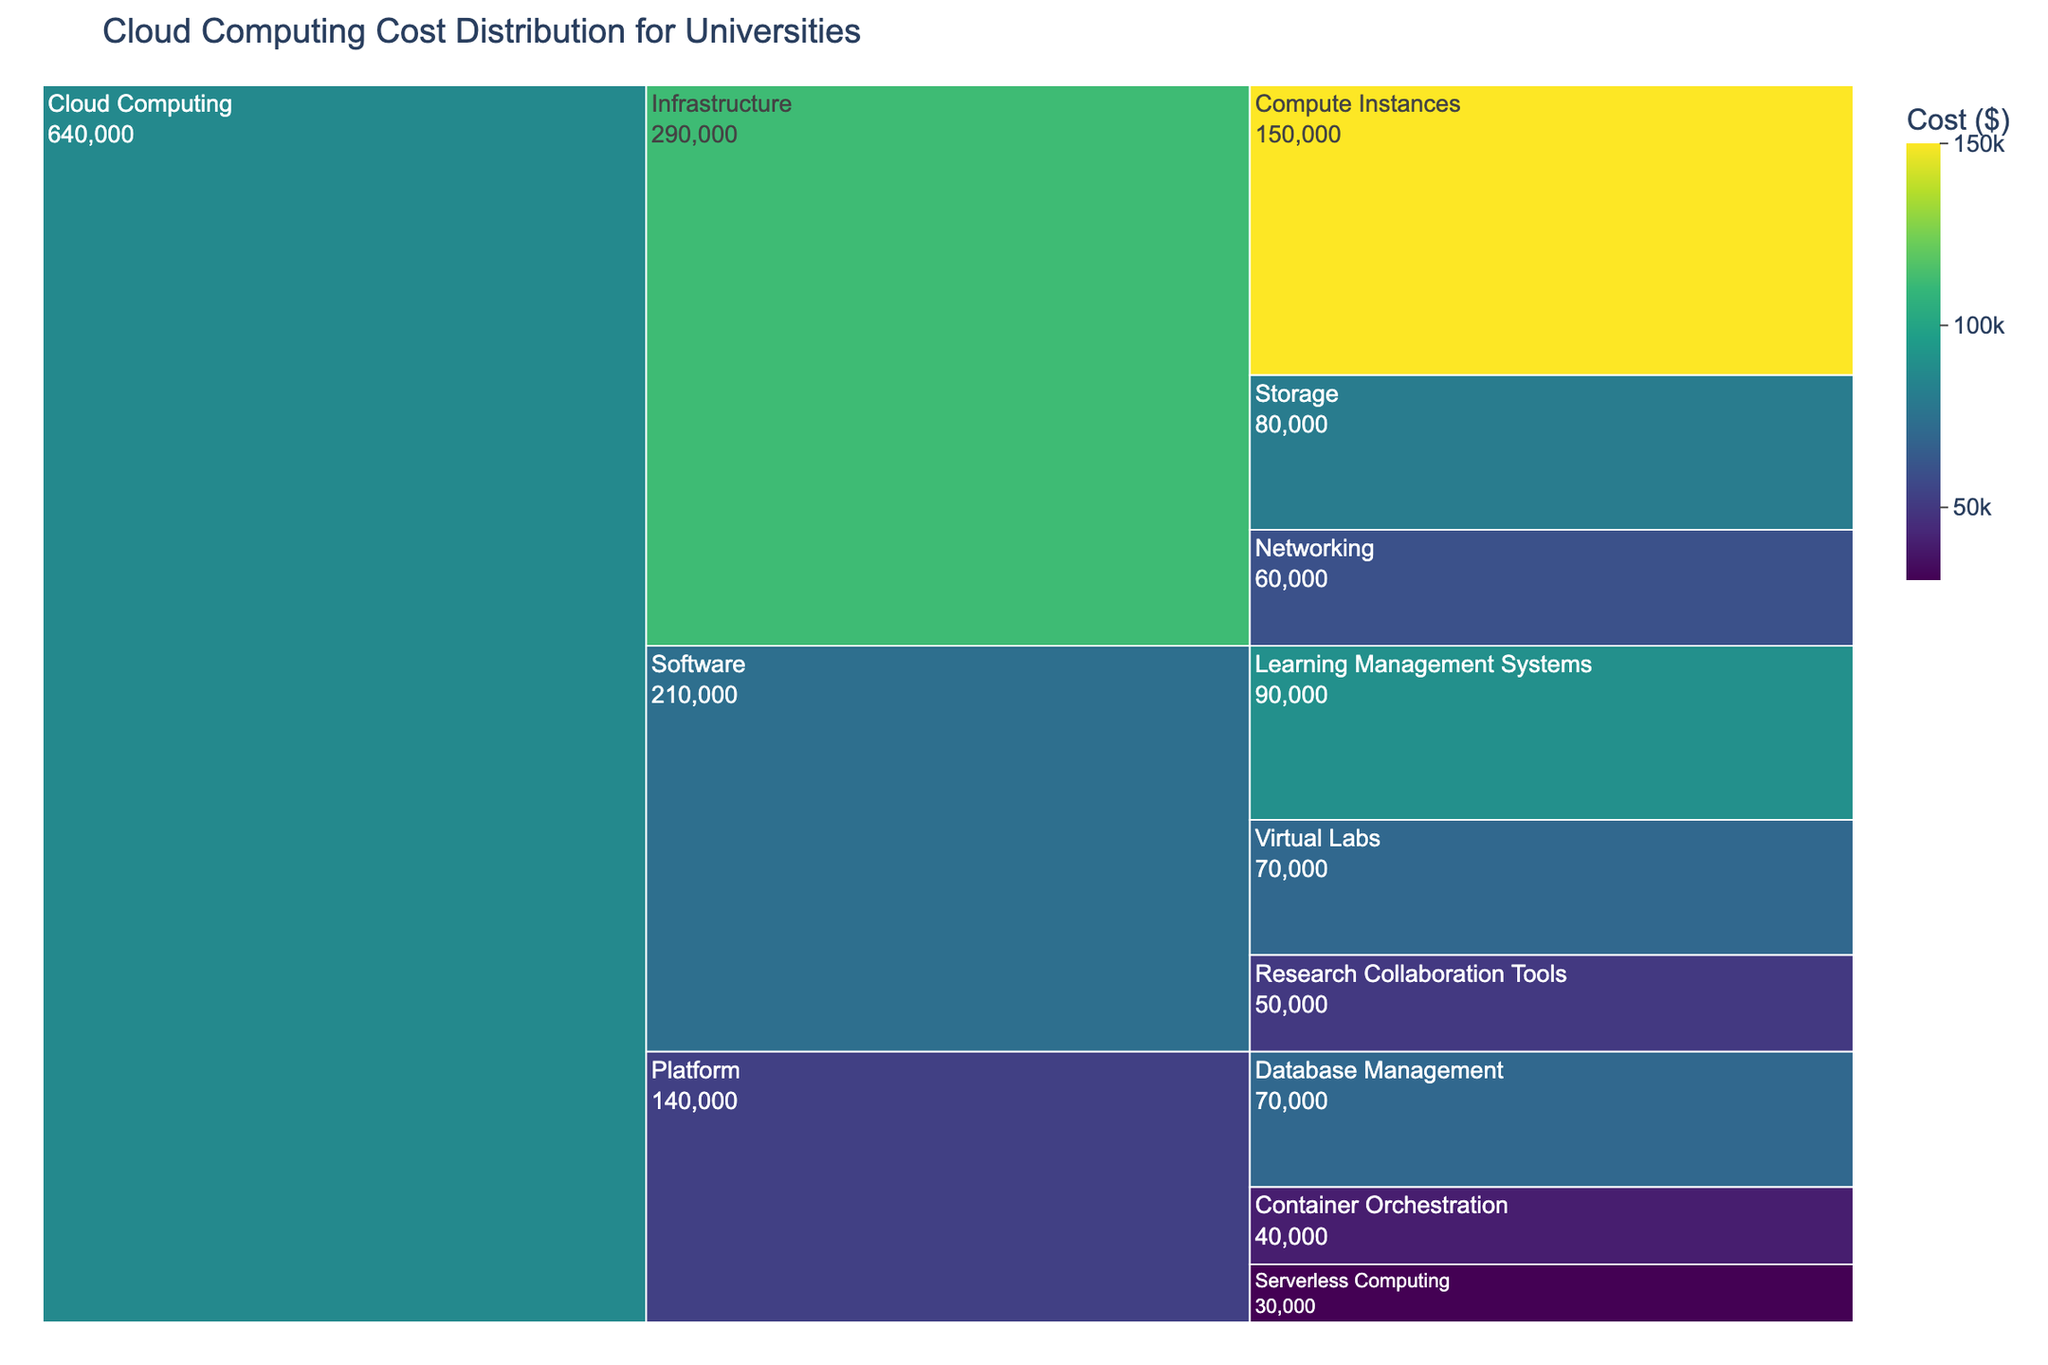What is the title of the chart? The title is typically placed at the top of the chart and is meant to concisely describe the subject of the visualization. In this case, the title is given in the code that generates the chart.
Answer: Cloud Computing Cost Distribution for Universities Which subcategory has the highest cost within Infrastructure services? Look at the segments under the Infrastructure category and identify which one has the highest value for cost. Compute Instances, Storage, and Networking are the subcategories.
Answer: Compute Instances What is the total cost of Infrastructure services? Sum the costs of all subcategories under the Infrastructure category. Add 150000 (Compute Instances), 80000 (Storage), and 60000 (Networking).
Answer: 290000 Compare the costs of Learning Management Systems and Virtual Labs. Which one is higher? Find both Learning Management Systems and Virtual Labs in the Software category and compare their costs. Learning Management Systems cost 90000, while Virtual Labs cost 70000.
Answer: Learning Management Systems What is the combined cost of all Software services? Sum the costs of all subcategories under the Software category: 90000 (Learning Management Systems), 50000 (Research Collaboration Tools), and 70000 (Virtual Labs).
Answer: 210000 How does the cost of Container Orchestration compare to Serverless Computing? Both these subcategories are under the Platform category. Compare their costs: Container Orchestration costs 40000 while Serverless Computing costs 30000.
Answer: Container Orchestration is higher Which Service has the smallest total cost, and what is that cost? Sum the costs of each service (Infrastructure, Platform, Software) and compare them. Infrastructure: 290000, Platform: 140000, Software: 210000. The smallest total is for the Platform service.
Answer: Platform, 140000 What is the difference in cost between the most expensive and the least expensive services within the Software category? Identify the highest and lowest costs in the Software category: Learning Management Systems (90000) and Research Collaboration Tools (50000). Subtract the smallest cost from the highest.
Answer: 40000 What percentage of the total cloud computing cost is attributed to Platform services? First, calculate the total cloud computing cost by summing all costs: 290000 (Infrastructure) + 140000 (Platform) + 210000 (Software) = 640000. Then find the percentage: (140000 / 640000) * 100%.
Answer: 21.88% 